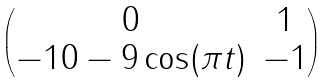Convert formula to latex. <formula><loc_0><loc_0><loc_500><loc_500>\begin{pmatrix} 0 & 1 \\ - 1 0 - 9 \cos ( \pi t ) & - 1 \end{pmatrix}</formula> 